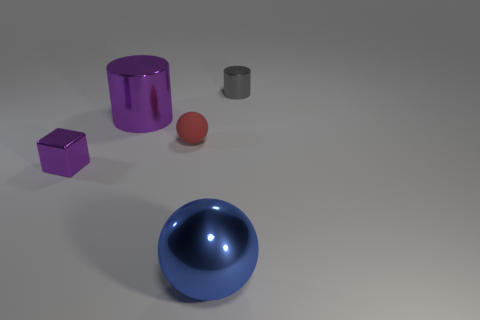Add 4 purple metallic blocks. How many objects exist? 9 Subtract all balls. How many objects are left? 3 Add 4 large purple things. How many large purple things are left? 5 Add 2 purple things. How many purple things exist? 4 Subtract 0 yellow balls. How many objects are left? 5 Subtract all cyan blocks. Subtract all yellow cylinders. How many blocks are left? 1 Subtract all metallic balls. Subtract all tiny matte spheres. How many objects are left? 3 